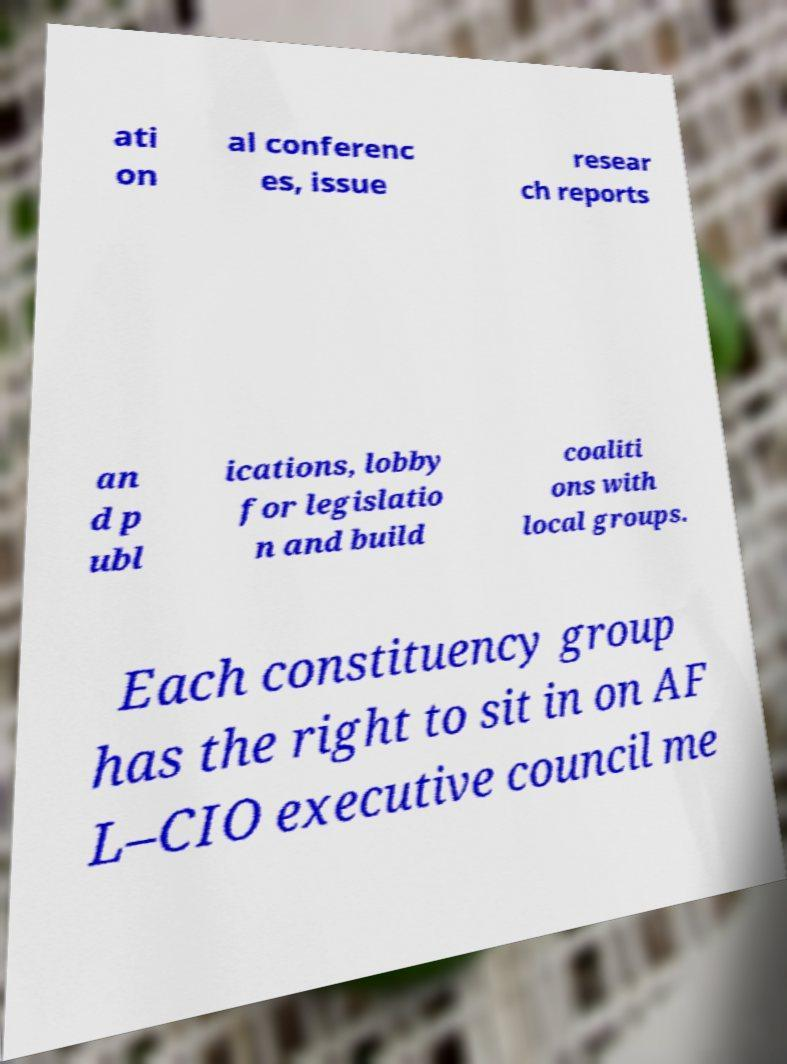Can you read and provide the text displayed in the image?This photo seems to have some interesting text. Can you extract and type it out for me? ati on al conferenc es, issue resear ch reports an d p ubl ications, lobby for legislatio n and build coaliti ons with local groups. Each constituency group has the right to sit in on AF L–CIO executive council me 